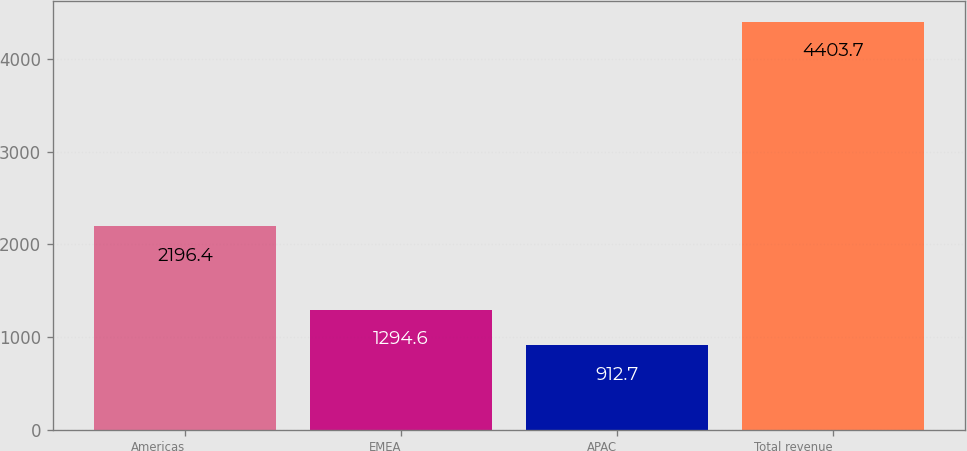<chart> <loc_0><loc_0><loc_500><loc_500><bar_chart><fcel>Americas<fcel>EMEA<fcel>APAC<fcel>Total revenue<nl><fcel>2196.4<fcel>1294.6<fcel>912.7<fcel>4403.7<nl></chart> 